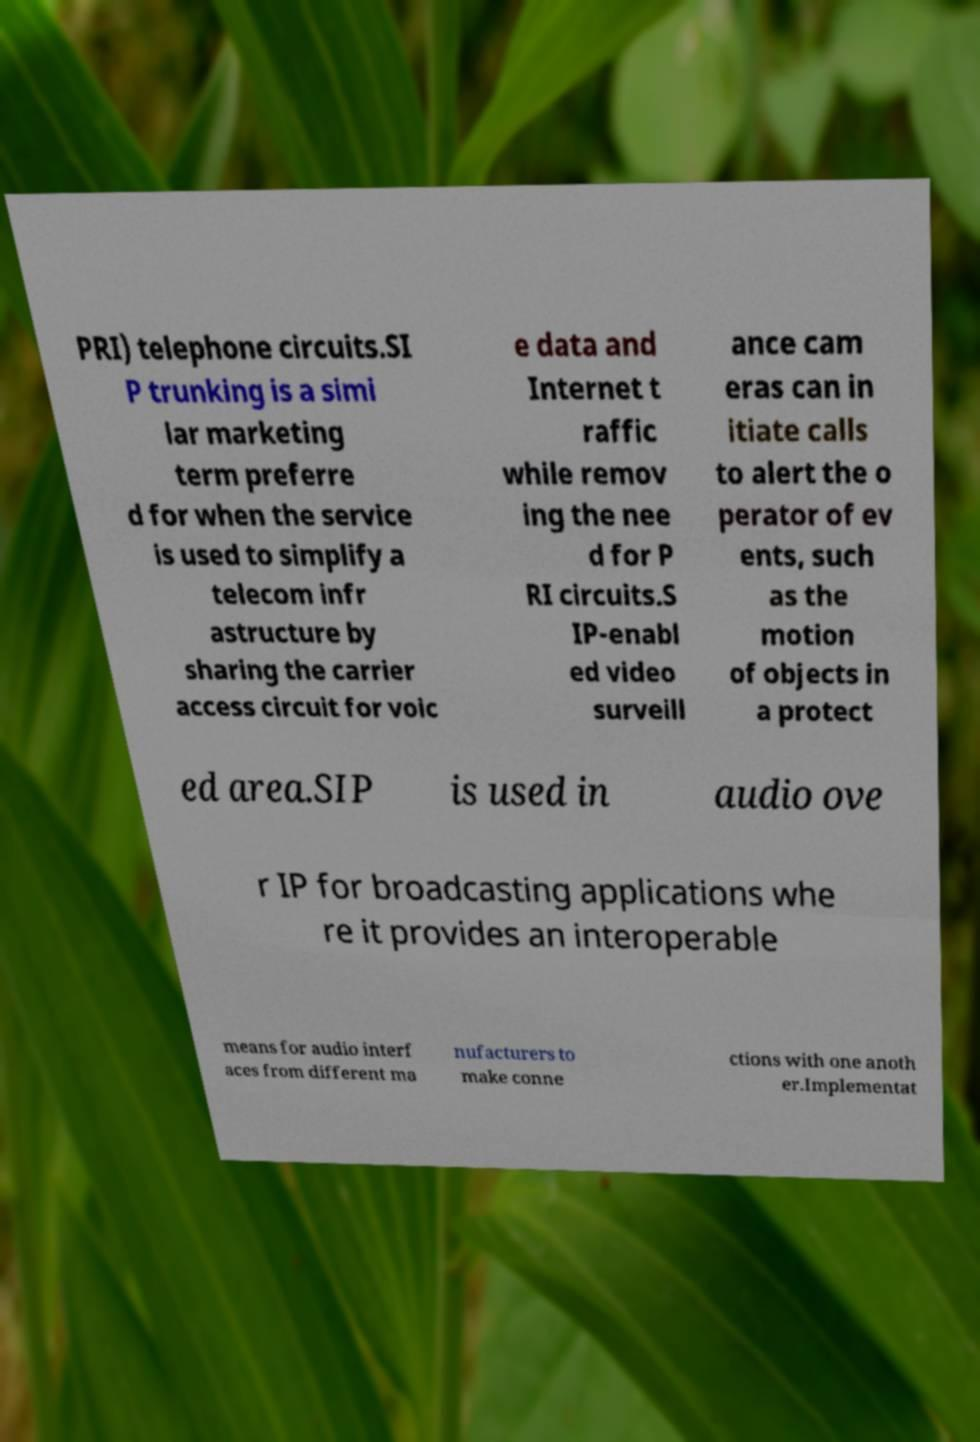What messages or text are displayed in this image? I need them in a readable, typed format. PRI) telephone circuits.SI P trunking is a simi lar marketing term preferre d for when the service is used to simplify a telecom infr astructure by sharing the carrier access circuit for voic e data and Internet t raffic while remov ing the nee d for P RI circuits.S IP-enabl ed video surveill ance cam eras can in itiate calls to alert the o perator of ev ents, such as the motion of objects in a protect ed area.SIP is used in audio ove r IP for broadcasting applications whe re it provides an interoperable means for audio interf aces from different ma nufacturers to make conne ctions with one anoth er.Implementat 